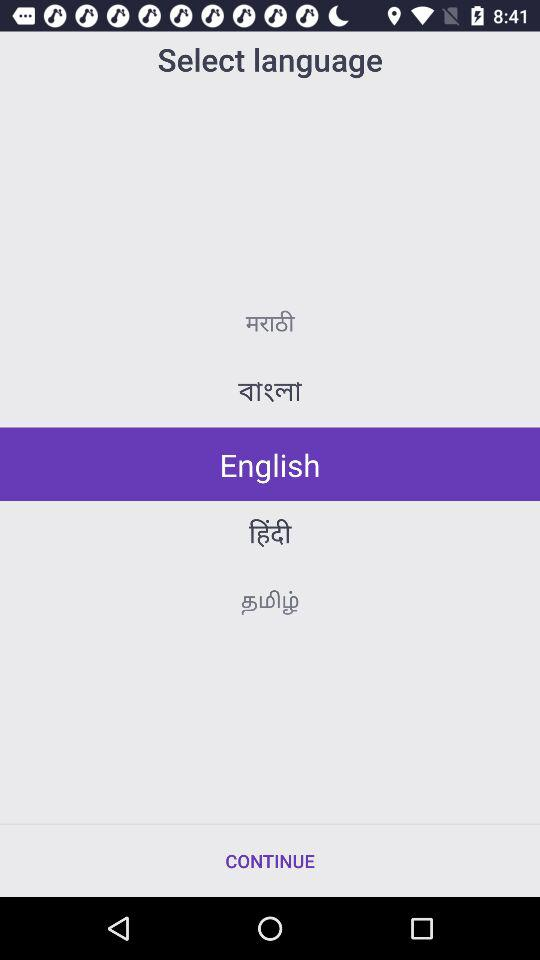How many languages are available on this screen?
Answer the question using a single word or phrase. 5 